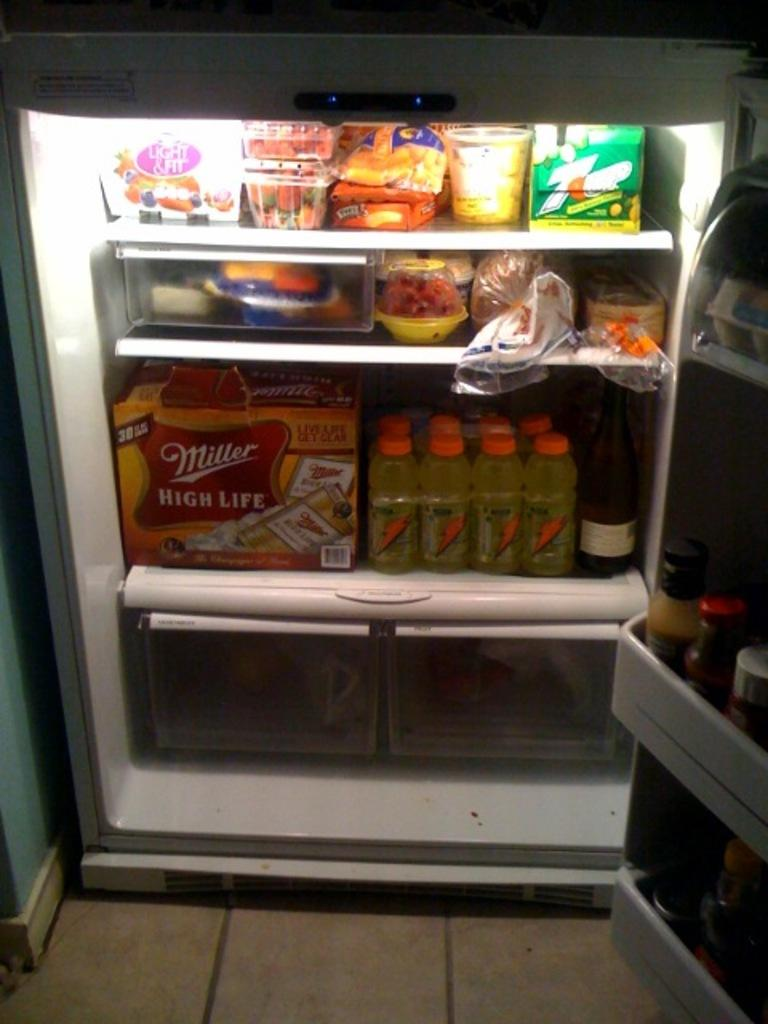<image>
Offer a succinct explanation of the picture presented. An open fridge reveals many drinks life Miller High Life and sports drinks. 